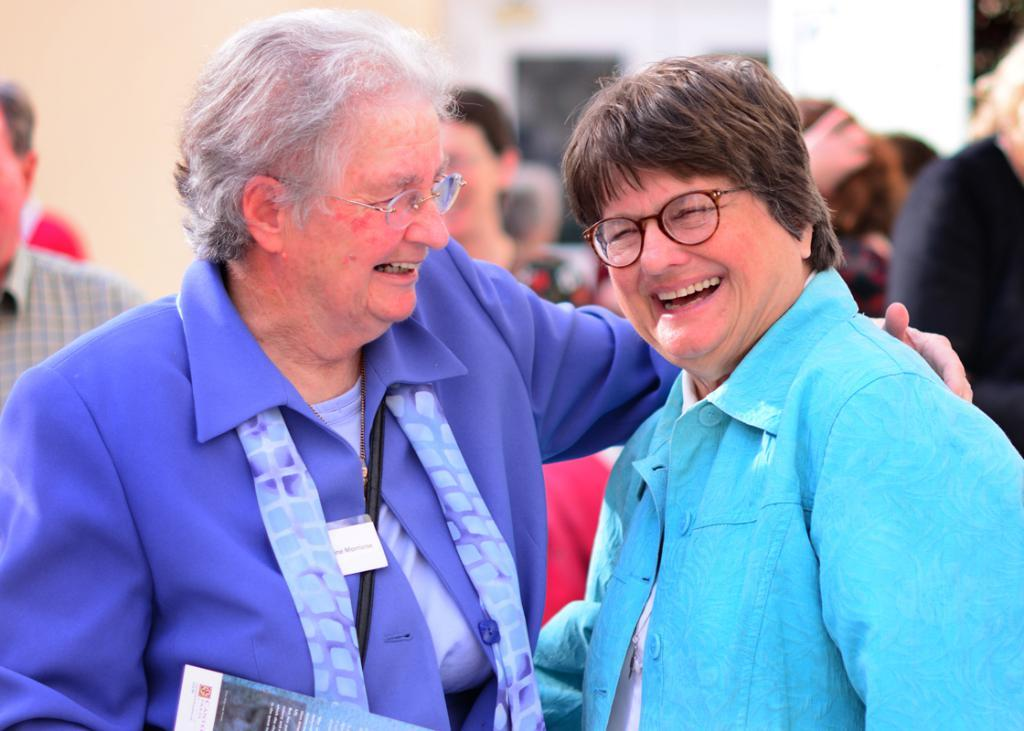How many people are in the image? There is a group of persons standing in the image. What colors are the dresses of the two persons mentioned? Two persons are wearing blue and sky blue color dresses. What are the two persons doing in the image? The two persons are hugging each other and laughing. Can you see a bee buzzing around the persons in the image? There is no bee present in the image. What yard are the persons standing in? The image does not specify a yard or any outdoor setting; it only shows the persons standing. 